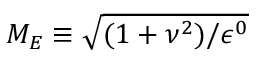<formula> <loc_0><loc_0><loc_500><loc_500>M _ { E } \equiv \sqrt { ( { 1 + \nu ^ { 2 } } ) / { \epsilon ^ { 0 } } }</formula> 